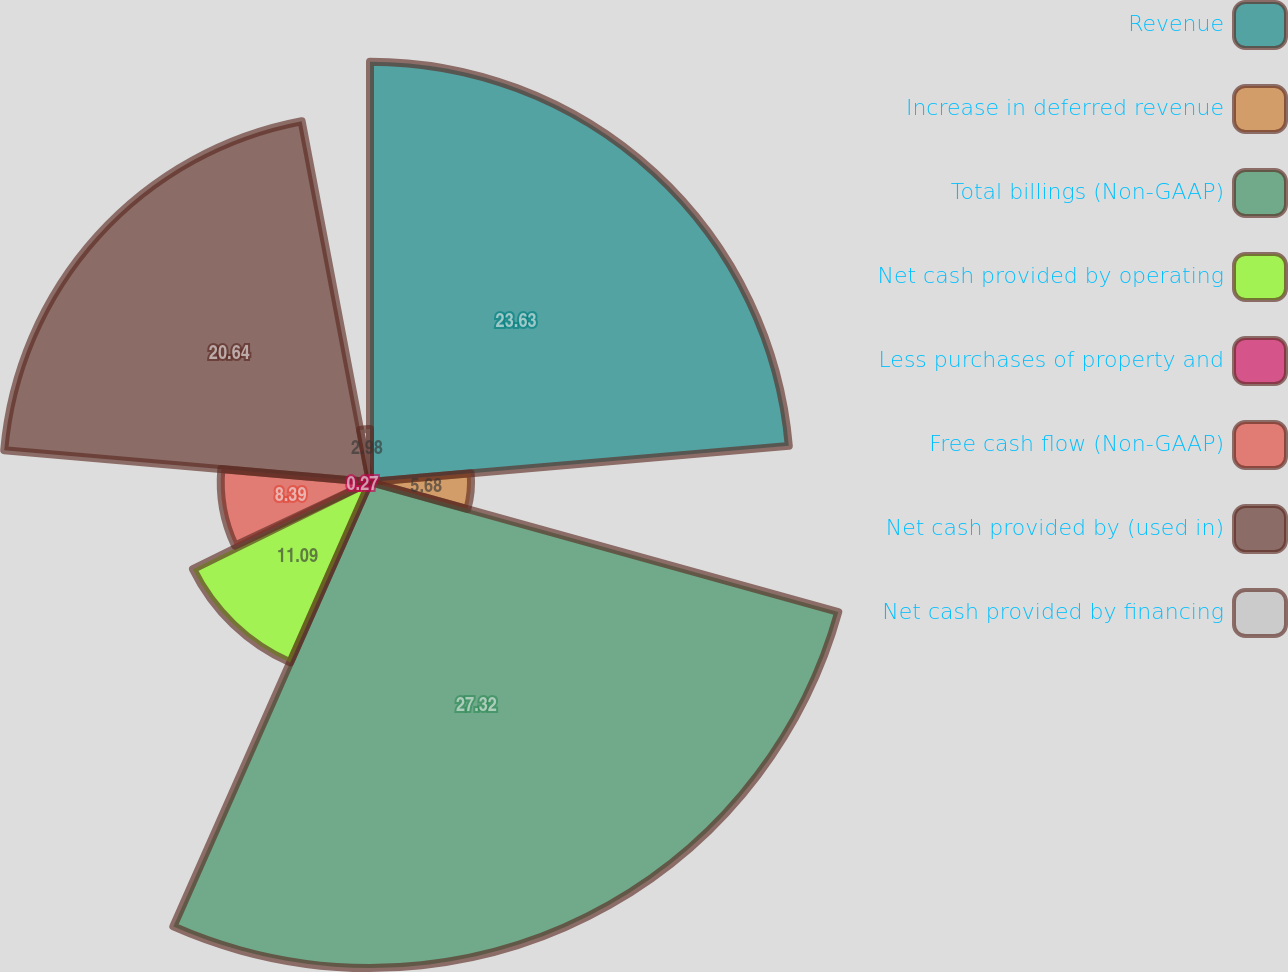<chart> <loc_0><loc_0><loc_500><loc_500><pie_chart><fcel>Revenue<fcel>Increase in deferred revenue<fcel>Total billings (Non-GAAP)<fcel>Net cash provided by operating<fcel>Less purchases of property and<fcel>Free cash flow (Non-GAAP)<fcel>Net cash provided by (used in)<fcel>Net cash provided by financing<nl><fcel>23.63%<fcel>5.68%<fcel>27.32%<fcel>11.09%<fcel>0.27%<fcel>8.39%<fcel>20.64%<fcel>2.98%<nl></chart> 